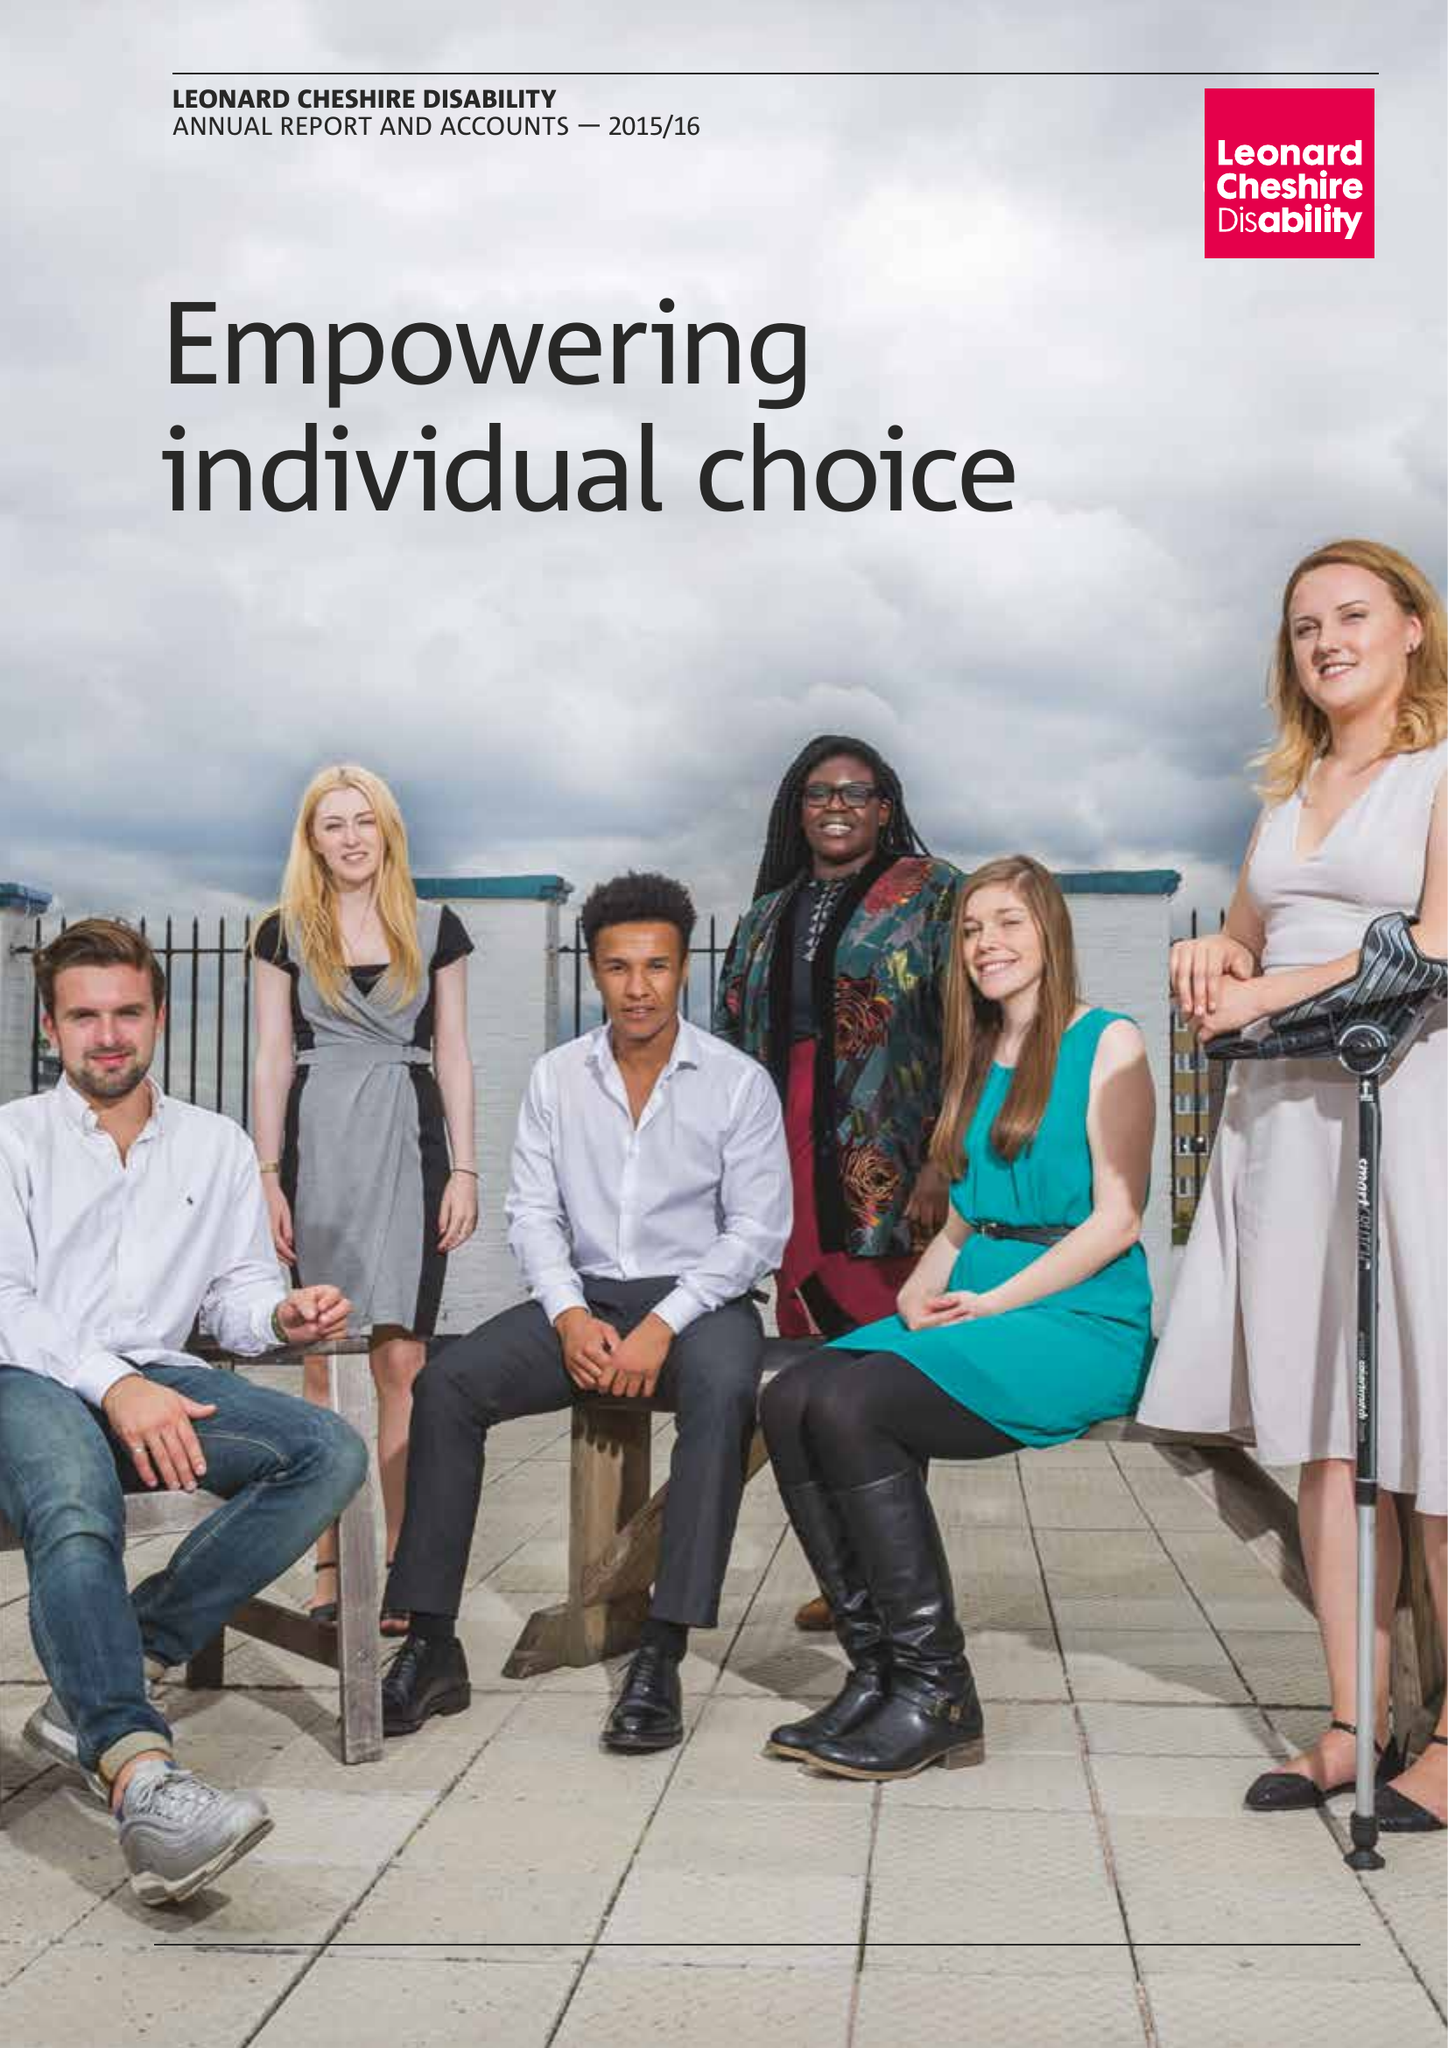What is the value for the address__street_line?
Answer the question using a single word or phrase. 66 SOUTH LAMBETH ROAD 